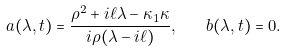Convert formula to latex. <formula><loc_0><loc_0><loc_500><loc_500>a ( \lambda , t ) = \frac { \rho ^ { 2 } + i \ell \lambda - \kappa _ { 1 } \kappa } { i \rho ( \lambda - i \ell ) } , \quad b ( \lambda , t ) = 0 .</formula> 